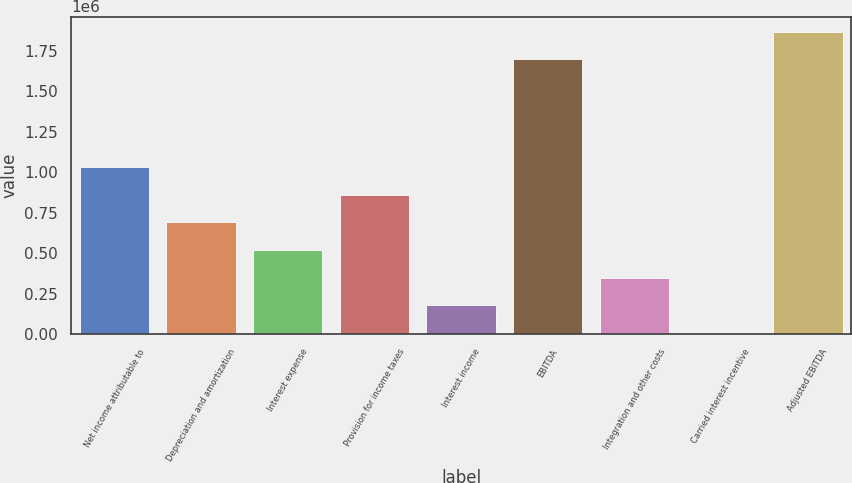Convert chart. <chart><loc_0><loc_0><loc_500><loc_500><bar_chart><fcel>Net income attributable to<fcel>Depreciation and amortization<fcel>Interest expense<fcel>Provision for income taxes<fcel>Interest income<fcel>EBITDA<fcel>Integration and other costs<fcel>Carried interest incentive<fcel>Adjusted EBITDA<nl><fcel>1.03347e+06<fcel>691820<fcel>520995<fcel>862646<fcel>179344<fcel>1.69794e+06<fcel>350169<fcel>8518<fcel>1.86877e+06<nl></chart> 